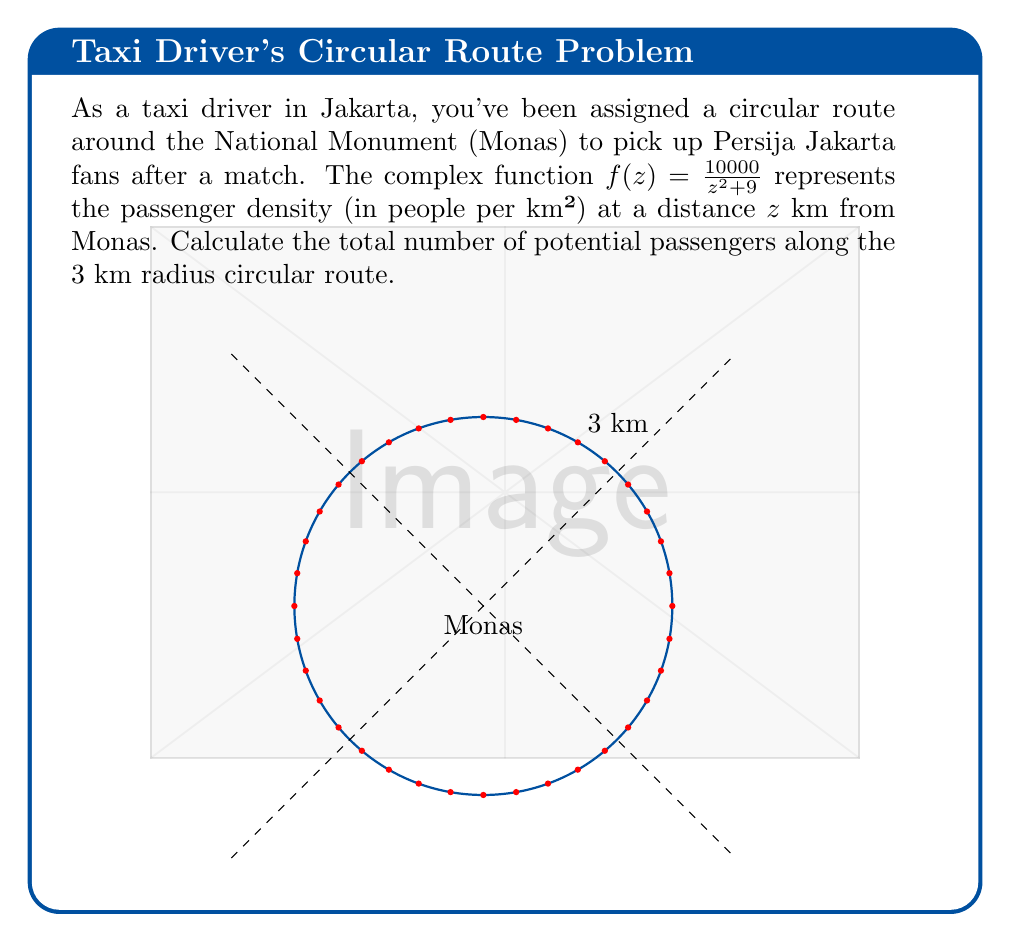Can you answer this question? Let's approach this step-by-step using complex analysis:

1) The total number of passengers is given by the line integral of $f(z)$ along the circular path:

   $$N = \oint_{|z|=3} f(z) dz$$

2) We can solve this using the residue theorem:

   $$N = 2\pi i \sum \text{Res}[f(z), z_k]$$

   where $z_k$ are the poles of $f(z)$ inside the contour.

3) The poles of $f(z)$ are at $z = \pm 3i$. Only $z = 3i$ is inside our contour.

4) To find the residue at $z = 3i$, we use:

   $$\text{Res}[f(z), 3i] = \lim_{z \to 3i} (z-3i)f(z)$$

5) Calculating:
   
   $$\begin{align}
   \text{Res}[f(z), 3i] &= \lim_{z \to 3i} (z-3i)\frac{10000}{z^2 + 9} \\
   &= \lim_{z \to 3i} \frac{10000(z-3i)}{(z+3i)(z-3i)} \\
   &= \frac{10000}{z+3i}\bigg|_{z=3i} \\
   &= \frac{10000}{6i} \\
   &= -\frac{5000}{3}i
   \end{align}$$

6) Applying the residue theorem:

   $$N = 2\pi i \cdot \left(-\frac{5000}{3}i\right) = \frac{10000\pi}{3}$$

Therefore, the total number of potential passengers along the route is $\frac{10000\pi}{3}$.
Answer: $\frac{10000\pi}{3}$ passengers 